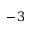Convert formula to latex. <formula><loc_0><loc_0><loc_500><loc_500>- 3</formula> 